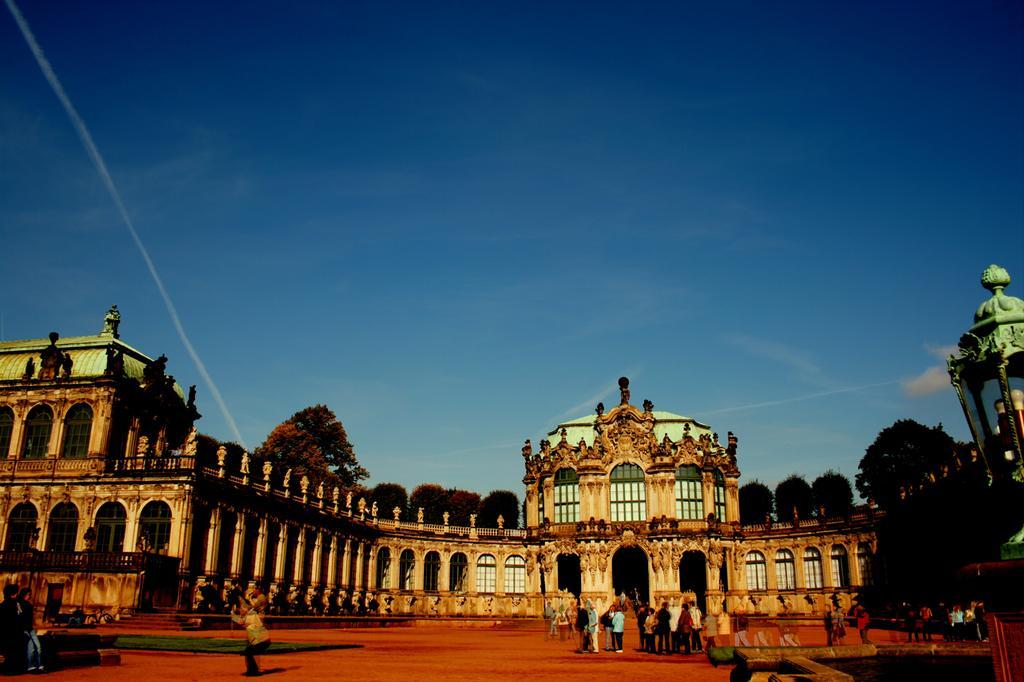Could you give a brief overview of what you see in this image? In the center of the image there is a palace. At the bottom there are people. In the background there are trees and sky. 